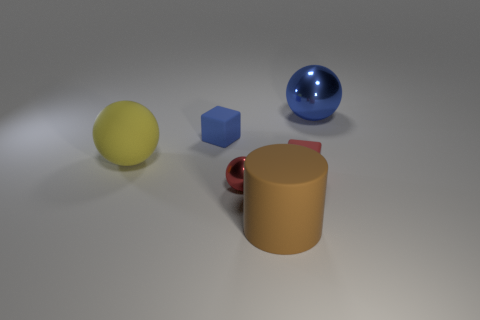Is the big yellow sphere made of the same material as the blue object that is to the right of the brown rubber thing?
Make the answer very short. No. There is a small thing that is the same color as the big metal object; what is its material?
Ensure brevity in your answer.  Rubber. What material is the yellow thing that is the same size as the brown rubber cylinder?
Ensure brevity in your answer.  Rubber. How many other objects are there of the same color as the small shiny ball?
Give a very brief answer. 1. There is a thing that is on the right side of the big brown cylinder and in front of the large yellow object; what material is it?
Your answer should be very brief. Rubber. What is the shape of the tiny thing that is behind the big yellow thing?
Make the answer very short. Cube. There is a shiny object behind the shiny thing that is left of the large shiny sphere; is there a yellow rubber thing that is to the right of it?
Provide a short and direct response. No. Is there any other thing that is the same shape as the large brown object?
Provide a short and direct response. No. Is there a large blue metal sphere?
Provide a succinct answer. Yes. Is the material of the large sphere that is on the left side of the blue metal thing the same as the sphere on the right side of the tiny metallic thing?
Offer a very short reply. No. 